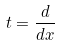Convert formula to latex. <formula><loc_0><loc_0><loc_500><loc_500>t = \frac { d } { d x }</formula> 